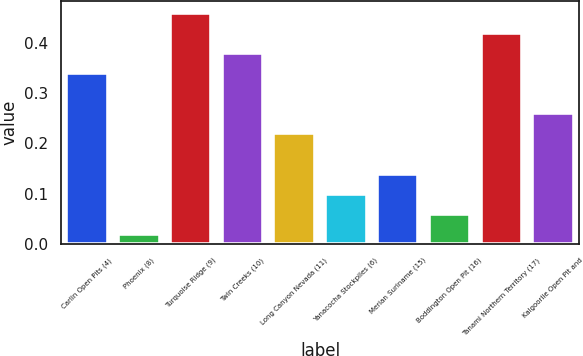Convert chart to OTSL. <chart><loc_0><loc_0><loc_500><loc_500><bar_chart><fcel>Carlin Open Pits (4)<fcel>Phoenix (8)<fcel>Turquoise Ridge (9)<fcel>Twin Creeks (10)<fcel>Long Canyon Nevada (11)<fcel>Yanacocha Stockpiles (6)<fcel>Merian Suriname (15)<fcel>Boddington Open Pit (16)<fcel>Tanami Northern Territory (17)<fcel>Kalgoorlie Open Pit and<nl><fcel>0.34<fcel>0.02<fcel>0.46<fcel>0.38<fcel>0.22<fcel>0.1<fcel>0.14<fcel>0.06<fcel>0.42<fcel>0.26<nl></chart> 